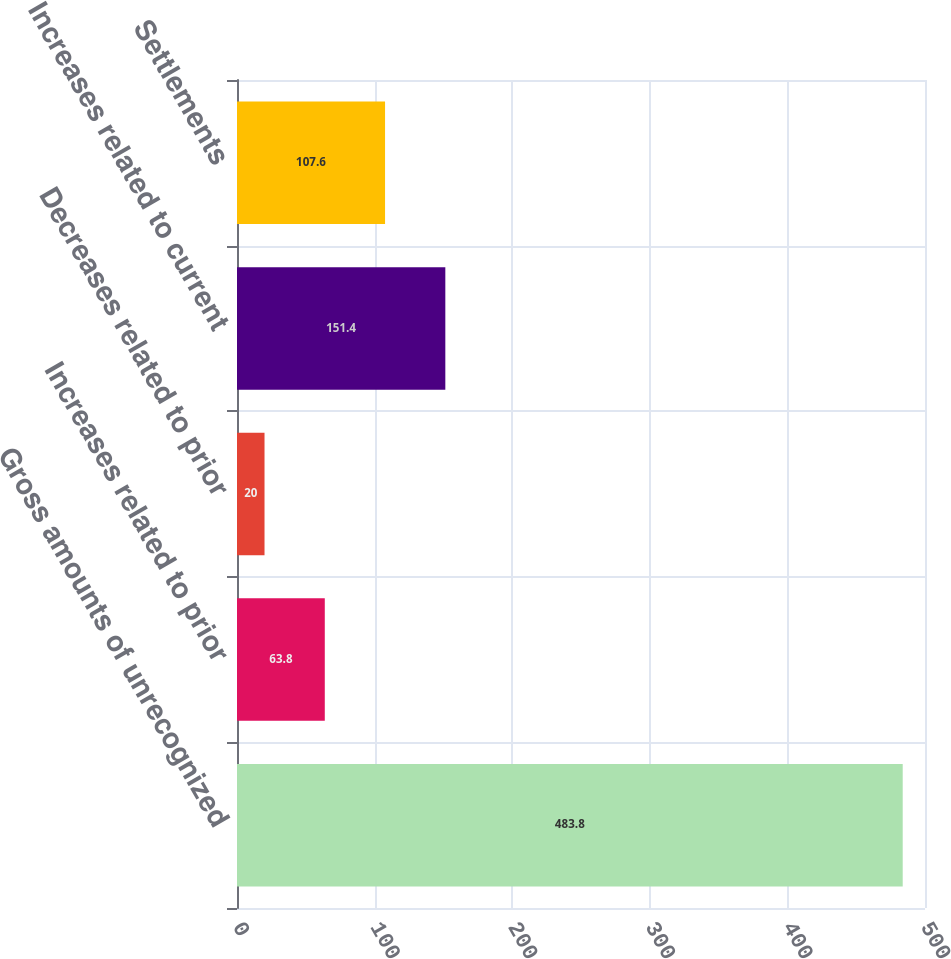<chart> <loc_0><loc_0><loc_500><loc_500><bar_chart><fcel>Gross amounts of unrecognized<fcel>Increases related to prior<fcel>Decreases related to prior<fcel>Increases related to current<fcel>Settlements<nl><fcel>483.8<fcel>63.8<fcel>20<fcel>151.4<fcel>107.6<nl></chart> 